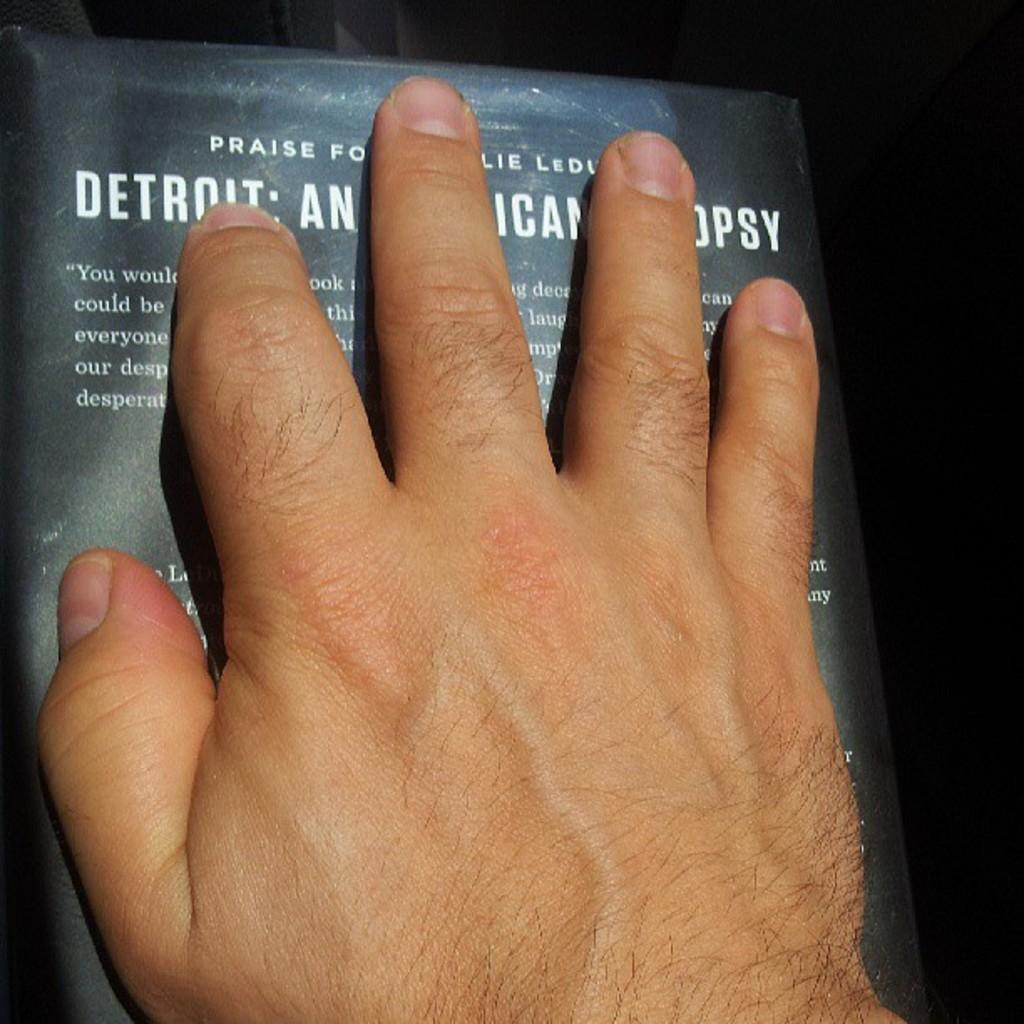What can be seen in the image related to a person? There is a hand of a person in the image. What is the hand doing in the image? The hand is placed on a book. How many pears can be seen on the slope in the image? There are no pears or slopes present in the image; it only features a hand placed on a book. 